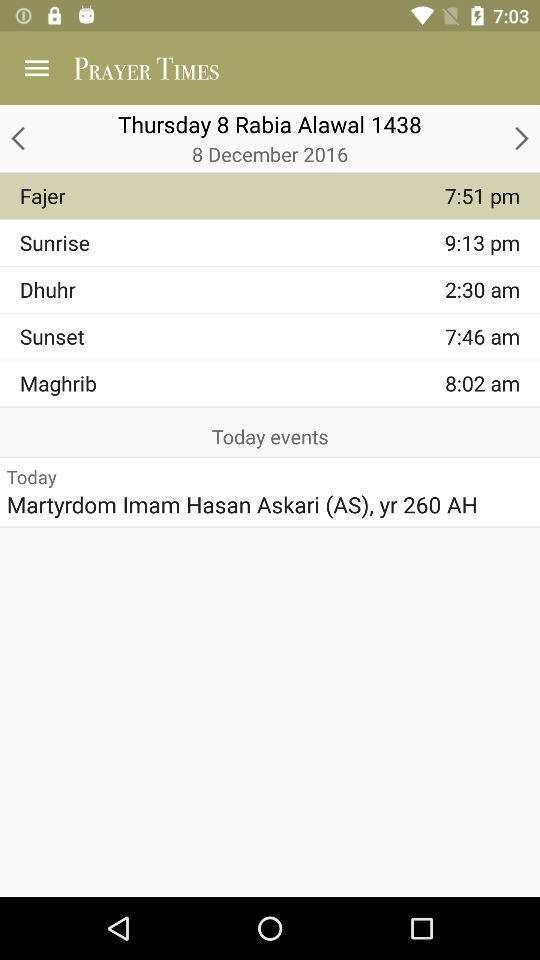What is the prayer time of "Maghrib"? The prayer time of "Maghrib" is 8:02 am. 